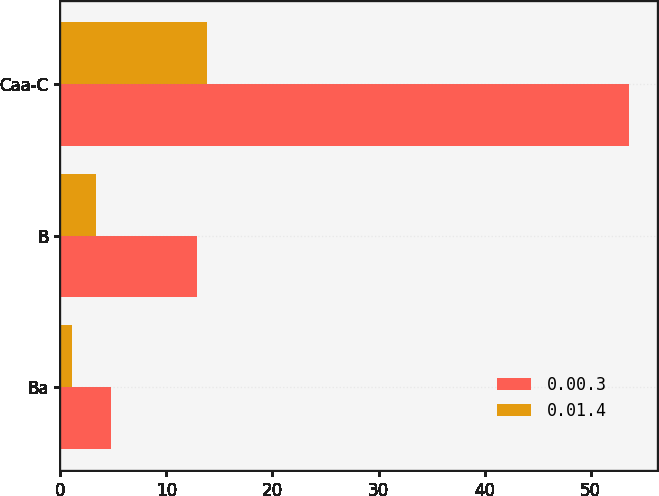Convert chart to OTSL. <chart><loc_0><loc_0><loc_500><loc_500><stacked_bar_chart><ecel><fcel>Ba<fcel>B<fcel>Caa-C<nl><fcel>0.00.3<fcel>4.8<fcel>12.9<fcel>53.6<nl><fcel>0.01.4<fcel>1.1<fcel>3.4<fcel>13.8<nl></chart> 